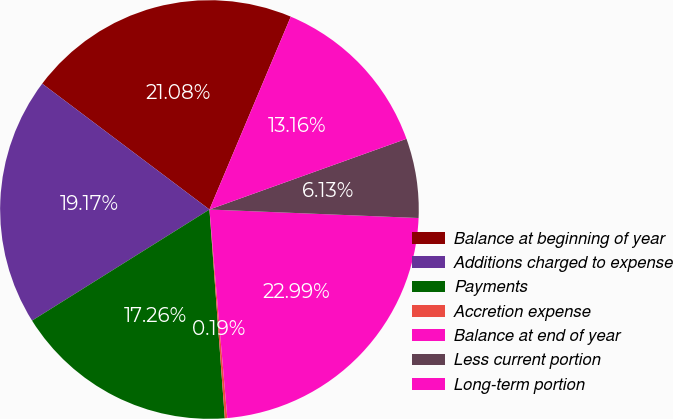Convert chart. <chart><loc_0><loc_0><loc_500><loc_500><pie_chart><fcel>Balance at beginning of year<fcel>Additions charged to expense<fcel>Payments<fcel>Accretion expense<fcel>Balance at end of year<fcel>Less current portion<fcel>Long-term portion<nl><fcel>21.08%<fcel>19.17%<fcel>17.26%<fcel>0.19%<fcel>22.99%<fcel>6.13%<fcel>13.16%<nl></chart> 